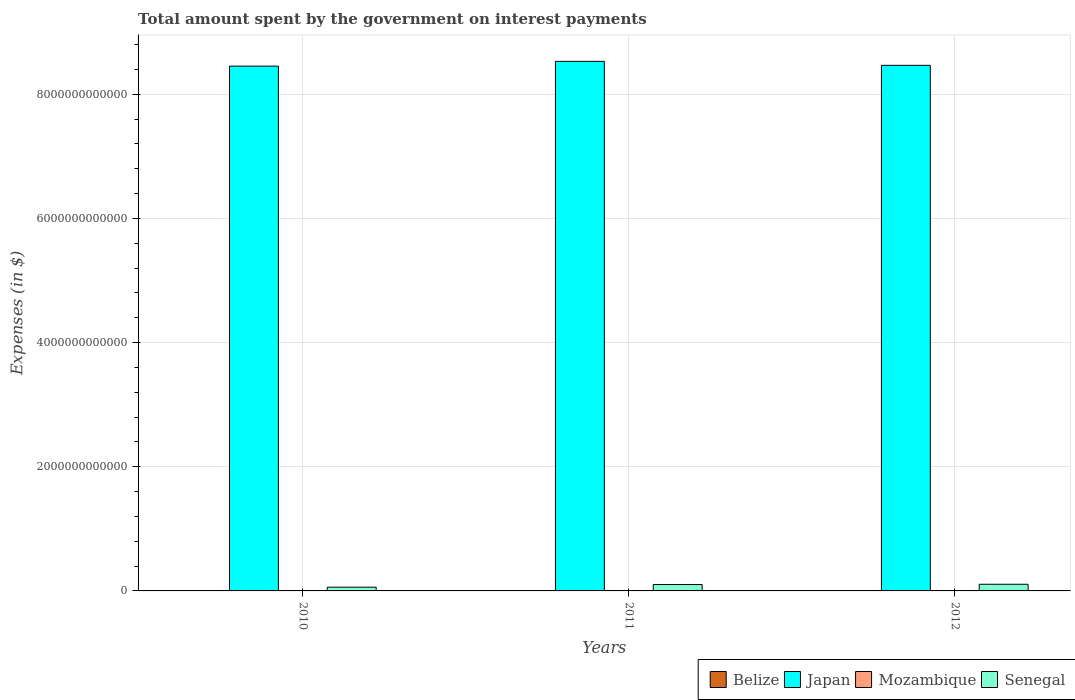How many different coloured bars are there?
Your answer should be very brief. 4. How many groups of bars are there?
Your response must be concise. 3. Are the number of bars per tick equal to the number of legend labels?
Your response must be concise. Yes. Are the number of bars on each tick of the X-axis equal?
Your answer should be compact. Yes. What is the label of the 3rd group of bars from the left?
Offer a terse response. 2012. In how many cases, is the number of bars for a given year not equal to the number of legend labels?
Give a very brief answer. 0. What is the amount spent on interest payments by the government in Mozambique in 2012?
Make the answer very short. 4.13e+09. Across all years, what is the maximum amount spent on interest payments by the government in Belize?
Your response must be concise. 1.03e+08. Across all years, what is the minimum amount spent on interest payments by the government in Mozambique?
Give a very brief answer. 2.67e+09. In which year was the amount spent on interest payments by the government in Belize minimum?
Keep it short and to the point. 2012. What is the total amount spent on interest payments by the government in Belize in the graph?
Make the answer very short. 2.65e+08. What is the difference between the amount spent on interest payments by the government in Senegal in 2010 and that in 2012?
Provide a succinct answer. -4.72e+1. What is the difference between the amount spent on interest payments by the government in Senegal in 2011 and the amount spent on interest payments by the government in Mozambique in 2012?
Make the answer very short. 9.86e+1. What is the average amount spent on interest payments by the government in Mozambique per year?
Provide a short and direct response. 3.43e+09. In the year 2010, what is the difference between the amount spent on interest payments by the government in Japan and amount spent on interest payments by the government in Belize?
Keep it short and to the point. 8.45e+12. In how many years, is the amount spent on interest payments by the government in Mozambique greater than 800000000000 $?
Offer a very short reply. 0. What is the ratio of the amount spent on interest payments by the government in Japan in 2010 to that in 2012?
Provide a succinct answer. 1. Is the difference between the amount spent on interest payments by the government in Japan in 2010 and 2011 greater than the difference between the amount spent on interest payments by the government in Belize in 2010 and 2011?
Keep it short and to the point. No. What is the difference between the highest and the second highest amount spent on interest payments by the government in Mozambique?
Offer a very short reply. 6.24e+08. What is the difference between the highest and the lowest amount spent on interest payments by the government in Senegal?
Your answer should be very brief. 4.72e+1. In how many years, is the amount spent on interest payments by the government in Belize greater than the average amount spent on interest payments by the government in Belize taken over all years?
Offer a very short reply. 2. What does the 4th bar from the left in 2012 represents?
Your answer should be compact. Senegal. What does the 2nd bar from the right in 2012 represents?
Give a very brief answer. Mozambique. Is it the case that in every year, the sum of the amount spent on interest payments by the government in Belize and amount spent on interest payments by the government in Mozambique is greater than the amount spent on interest payments by the government in Japan?
Your answer should be very brief. No. How many bars are there?
Your answer should be very brief. 12. Are all the bars in the graph horizontal?
Offer a very short reply. No. How many years are there in the graph?
Your answer should be compact. 3. What is the difference between two consecutive major ticks on the Y-axis?
Keep it short and to the point. 2.00e+12. Are the values on the major ticks of Y-axis written in scientific E-notation?
Provide a succinct answer. No. Does the graph contain any zero values?
Give a very brief answer. No. Does the graph contain grids?
Give a very brief answer. Yes. Where does the legend appear in the graph?
Provide a short and direct response. Bottom right. How many legend labels are there?
Provide a succinct answer. 4. What is the title of the graph?
Ensure brevity in your answer.  Total amount spent by the government on interest payments. What is the label or title of the X-axis?
Provide a short and direct response. Years. What is the label or title of the Y-axis?
Provide a succinct answer. Expenses (in $). What is the Expenses (in $) of Belize in 2010?
Give a very brief answer. 1.03e+08. What is the Expenses (in $) in Japan in 2010?
Keep it short and to the point. 8.45e+12. What is the Expenses (in $) of Mozambique in 2010?
Your response must be concise. 2.67e+09. What is the Expenses (in $) in Senegal in 2010?
Keep it short and to the point. 6.01e+1. What is the Expenses (in $) in Belize in 2011?
Your response must be concise. 1.02e+08. What is the Expenses (in $) in Japan in 2011?
Offer a terse response. 8.53e+12. What is the Expenses (in $) of Mozambique in 2011?
Provide a succinct answer. 3.50e+09. What is the Expenses (in $) of Senegal in 2011?
Provide a short and direct response. 1.03e+11. What is the Expenses (in $) of Belize in 2012?
Your answer should be compact. 5.93e+07. What is the Expenses (in $) in Japan in 2012?
Your answer should be compact. 8.47e+12. What is the Expenses (in $) of Mozambique in 2012?
Offer a terse response. 4.13e+09. What is the Expenses (in $) of Senegal in 2012?
Your answer should be compact. 1.07e+11. Across all years, what is the maximum Expenses (in $) in Belize?
Keep it short and to the point. 1.03e+08. Across all years, what is the maximum Expenses (in $) of Japan?
Offer a terse response. 8.53e+12. Across all years, what is the maximum Expenses (in $) of Mozambique?
Keep it short and to the point. 4.13e+09. Across all years, what is the maximum Expenses (in $) of Senegal?
Your response must be concise. 1.07e+11. Across all years, what is the minimum Expenses (in $) of Belize?
Make the answer very short. 5.93e+07. Across all years, what is the minimum Expenses (in $) of Japan?
Offer a very short reply. 8.45e+12. Across all years, what is the minimum Expenses (in $) in Mozambique?
Make the answer very short. 2.67e+09. Across all years, what is the minimum Expenses (in $) in Senegal?
Offer a terse response. 6.01e+1. What is the total Expenses (in $) of Belize in the graph?
Keep it short and to the point. 2.65e+08. What is the total Expenses (in $) of Japan in the graph?
Ensure brevity in your answer.  2.55e+13. What is the total Expenses (in $) of Mozambique in the graph?
Provide a succinct answer. 1.03e+1. What is the total Expenses (in $) of Senegal in the graph?
Ensure brevity in your answer.  2.70e+11. What is the difference between the Expenses (in $) in Belize in 2010 and that in 2011?
Provide a succinct answer. 1.03e+06. What is the difference between the Expenses (in $) in Japan in 2010 and that in 2011?
Offer a very short reply. -7.70e+1. What is the difference between the Expenses (in $) of Mozambique in 2010 and that in 2011?
Offer a very short reply. -8.28e+08. What is the difference between the Expenses (in $) in Senegal in 2010 and that in 2011?
Keep it short and to the point. -4.26e+1. What is the difference between the Expenses (in $) of Belize in 2010 and that in 2012?
Make the answer very short. 4.41e+07. What is the difference between the Expenses (in $) in Japan in 2010 and that in 2012?
Your response must be concise. -1.28e+1. What is the difference between the Expenses (in $) of Mozambique in 2010 and that in 2012?
Make the answer very short. -1.45e+09. What is the difference between the Expenses (in $) in Senegal in 2010 and that in 2012?
Your answer should be very brief. -4.72e+1. What is the difference between the Expenses (in $) of Belize in 2011 and that in 2012?
Provide a succinct answer. 4.31e+07. What is the difference between the Expenses (in $) of Japan in 2011 and that in 2012?
Provide a short and direct response. 6.42e+1. What is the difference between the Expenses (in $) in Mozambique in 2011 and that in 2012?
Your answer should be very brief. -6.24e+08. What is the difference between the Expenses (in $) in Senegal in 2011 and that in 2012?
Offer a terse response. -4.60e+09. What is the difference between the Expenses (in $) in Belize in 2010 and the Expenses (in $) in Japan in 2011?
Ensure brevity in your answer.  -8.53e+12. What is the difference between the Expenses (in $) of Belize in 2010 and the Expenses (in $) of Mozambique in 2011?
Your answer should be very brief. -3.40e+09. What is the difference between the Expenses (in $) of Belize in 2010 and the Expenses (in $) of Senegal in 2011?
Your response must be concise. -1.03e+11. What is the difference between the Expenses (in $) in Japan in 2010 and the Expenses (in $) in Mozambique in 2011?
Keep it short and to the point. 8.45e+12. What is the difference between the Expenses (in $) of Japan in 2010 and the Expenses (in $) of Senegal in 2011?
Ensure brevity in your answer.  8.35e+12. What is the difference between the Expenses (in $) of Mozambique in 2010 and the Expenses (in $) of Senegal in 2011?
Give a very brief answer. -1.00e+11. What is the difference between the Expenses (in $) in Belize in 2010 and the Expenses (in $) in Japan in 2012?
Provide a succinct answer. -8.47e+12. What is the difference between the Expenses (in $) of Belize in 2010 and the Expenses (in $) of Mozambique in 2012?
Keep it short and to the point. -4.02e+09. What is the difference between the Expenses (in $) of Belize in 2010 and the Expenses (in $) of Senegal in 2012?
Ensure brevity in your answer.  -1.07e+11. What is the difference between the Expenses (in $) in Japan in 2010 and the Expenses (in $) in Mozambique in 2012?
Give a very brief answer. 8.45e+12. What is the difference between the Expenses (in $) in Japan in 2010 and the Expenses (in $) in Senegal in 2012?
Keep it short and to the point. 8.35e+12. What is the difference between the Expenses (in $) in Mozambique in 2010 and the Expenses (in $) in Senegal in 2012?
Ensure brevity in your answer.  -1.05e+11. What is the difference between the Expenses (in $) of Belize in 2011 and the Expenses (in $) of Japan in 2012?
Your answer should be compact. -8.47e+12. What is the difference between the Expenses (in $) of Belize in 2011 and the Expenses (in $) of Mozambique in 2012?
Give a very brief answer. -4.02e+09. What is the difference between the Expenses (in $) in Belize in 2011 and the Expenses (in $) in Senegal in 2012?
Your answer should be compact. -1.07e+11. What is the difference between the Expenses (in $) in Japan in 2011 and the Expenses (in $) in Mozambique in 2012?
Your response must be concise. 8.53e+12. What is the difference between the Expenses (in $) in Japan in 2011 and the Expenses (in $) in Senegal in 2012?
Give a very brief answer. 8.42e+12. What is the difference between the Expenses (in $) in Mozambique in 2011 and the Expenses (in $) in Senegal in 2012?
Give a very brief answer. -1.04e+11. What is the average Expenses (in $) in Belize per year?
Your response must be concise. 8.83e+07. What is the average Expenses (in $) of Japan per year?
Provide a short and direct response. 8.48e+12. What is the average Expenses (in $) of Mozambique per year?
Offer a terse response. 3.43e+09. What is the average Expenses (in $) in Senegal per year?
Make the answer very short. 9.00e+1. In the year 2010, what is the difference between the Expenses (in $) of Belize and Expenses (in $) of Japan?
Your response must be concise. -8.45e+12. In the year 2010, what is the difference between the Expenses (in $) in Belize and Expenses (in $) in Mozambique?
Keep it short and to the point. -2.57e+09. In the year 2010, what is the difference between the Expenses (in $) in Belize and Expenses (in $) in Senegal?
Your response must be concise. -6.00e+1. In the year 2010, what is the difference between the Expenses (in $) in Japan and Expenses (in $) in Mozambique?
Keep it short and to the point. 8.45e+12. In the year 2010, what is the difference between the Expenses (in $) in Japan and Expenses (in $) in Senegal?
Keep it short and to the point. 8.39e+12. In the year 2010, what is the difference between the Expenses (in $) of Mozambique and Expenses (in $) of Senegal?
Keep it short and to the point. -5.74e+1. In the year 2011, what is the difference between the Expenses (in $) of Belize and Expenses (in $) of Japan?
Your response must be concise. -8.53e+12. In the year 2011, what is the difference between the Expenses (in $) in Belize and Expenses (in $) in Mozambique?
Ensure brevity in your answer.  -3.40e+09. In the year 2011, what is the difference between the Expenses (in $) of Belize and Expenses (in $) of Senegal?
Give a very brief answer. -1.03e+11. In the year 2011, what is the difference between the Expenses (in $) of Japan and Expenses (in $) of Mozambique?
Provide a succinct answer. 8.53e+12. In the year 2011, what is the difference between the Expenses (in $) in Japan and Expenses (in $) in Senegal?
Provide a short and direct response. 8.43e+12. In the year 2011, what is the difference between the Expenses (in $) of Mozambique and Expenses (in $) of Senegal?
Make the answer very short. -9.92e+1. In the year 2012, what is the difference between the Expenses (in $) of Belize and Expenses (in $) of Japan?
Offer a very short reply. -8.47e+12. In the year 2012, what is the difference between the Expenses (in $) in Belize and Expenses (in $) in Mozambique?
Offer a very short reply. -4.07e+09. In the year 2012, what is the difference between the Expenses (in $) in Belize and Expenses (in $) in Senegal?
Make the answer very short. -1.07e+11. In the year 2012, what is the difference between the Expenses (in $) in Japan and Expenses (in $) in Mozambique?
Your answer should be very brief. 8.46e+12. In the year 2012, what is the difference between the Expenses (in $) in Japan and Expenses (in $) in Senegal?
Make the answer very short. 8.36e+12. In the year 2012, what is the difference between the Expenses (in $) of Mozambique and Expenses (in $) of Senegal?
Ensure brevity in your answer.  -1.03e+11. What is the ratio of the Expenses (in $) of Mozambique in 2010 to that in 2011?
Your answer should be compact. 0.76. What is the ratio of the Expenses (in $) of Senegal in 2010 to that in 2011?
Offer a very short reply. 0.58. What is the ratio of the Expenses (in $) of Belize in 2010 to that in 2012?
Give a very brief answer. 1.74. What is the ratio of the Expenses (in $) in Japan in 2010 to that in 2012?
Your response must be concise. 1. What is the ratio of the Expenses (in $) in Mozambique in 2010 to that in 2012?
Keep it short and to the point. 0.65. What is the ratio of the Expenses (in $) of Senegal in 2010 to that in 2012?
Keep it short and to the point. 0.56. What is the ratio of the Expenses (in $) in Belize in 2011 to that in 2012?
Make the answer very short. 1.73. What is the ratio of the Expenses (in $) of Japan in 2011 to that in 2012?
Provide a succinct answer. 1.01. What is the ratio of the Expenses (in $) of Mozambique in 2011 to that in 2012?
Keep it short and to the point. 0.85. What is the ratio of the Expenses (in $) in Senegal in 2011 to that in 2012?
Provide a short and direct response. 0.96. What is the difference between the highest and the second highest Expenses (in $) of Belize?
Your answer should be very brief. 1.03e+06. What is the difference between the highest and the second highest Expenses (in $) of Japan?
Make the answer very short. 6.42e+1. What is the difference between the highest and the second highest Expenses (in $) of Mozambique?
Your answer should be very brief. 6.24e+08. What is the difference between the highest and the second highest Expenses (in $) in Senegal?
Offer a terse response. 4.60e+09. What is the difference between the highest and the lowest Expenses (in $) in Belize?
Provide a short and direct response. 4.41e+07. What is the difference between the highest and the lowest Expenses (in $) in Japan?
Provide a short and direct response. 7.70e+1. What is the difference between the highest and the lowest Expenses (in $) of Mozambique?
Offer a terse response. 1.45e+09. What is the difference between the highest and the lowest Expenses (in $) of Senegal?
Your response must be concise. 4.72e+1. 